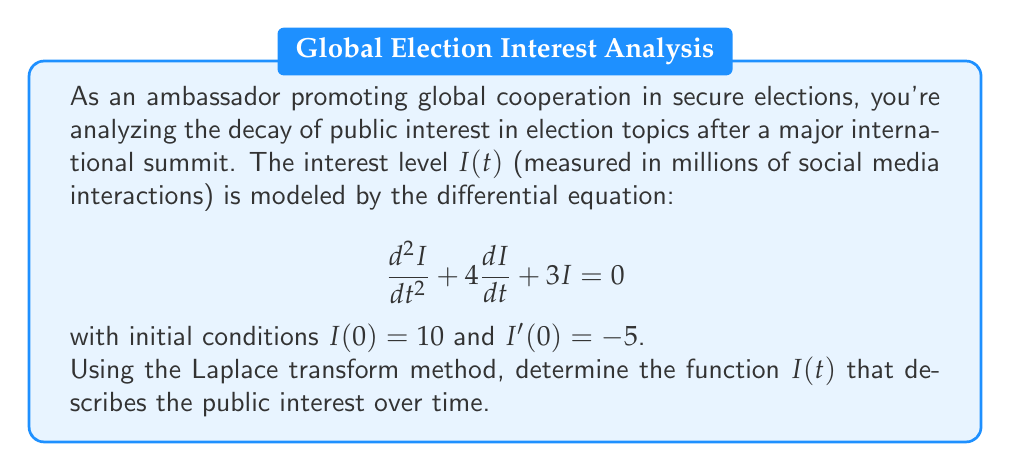Teach me how to tackle this problem. Let's solve this problem step by step using the Laplace transform method:

1) Take the Laplace transform of both sides of the differential equation:
   $$\mathcal{L}\{I''(t) + 4I'(t) + 3I(t)\} = \mathcal{L}\{0\}$$

2) Using Laplace transform properties:
   $$[s^2\mathcal{L}\{I(t)\} - sI(0) - I'(0)] + 4[s\mathcal{L}\{I(t)\} - I(0)] + 3\mathcal{L}\{I(t)\} = 0$$

3) Let $\mathcal{L}\{I(t)\} = Y(s)$. Substituting the initial conditions:
   $$s^2Y(s) - 10s + 5 + 4sY(s) - 40 + 3Y(s) = 0$$

4) Simplify:
   $$s^2Y(s) + 4sY(s) + 3Y(s) = 10s + 35$$
   $$(s^2 + 4s + 3)Y(s) = 10s + 35$$

5) Solve for Y(s):
   $$Y(s) = \frac{10s + 35}{s^2 + 4s + 3} = \frac{10s + 35}{(s+1)(s+3)}$$

6) Perform partial fraction decomposition:
   $$Y(s) = \frac{A}{s+1} + \frac{B}{s+3}$$
   
   Solving for A and B:
   $$10s + 35 = A(s+3) + B(s+1)$$
   $$A + B = 10$$
   $$3A + B = 35$$
   
   This gives us $A = 15$ and $B = -5$

7) Rewrite Y(s):
   $$Y(s) = \frac{15}{s+1} - \frac{5}{s+3}$$

8) Take the inverse Laplace transform:
   $$I(t) = 15e^{-t} - 5e^{-3t}$$

This is the function that describes the public interest over time.
Answer: $I(t) = 15e^{-t} - 5e^{-3t}$ 